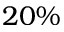Convert formula to latex. <formula><loc_0><loc_0><loc_500><loc_500>2 0 \%</formula> 